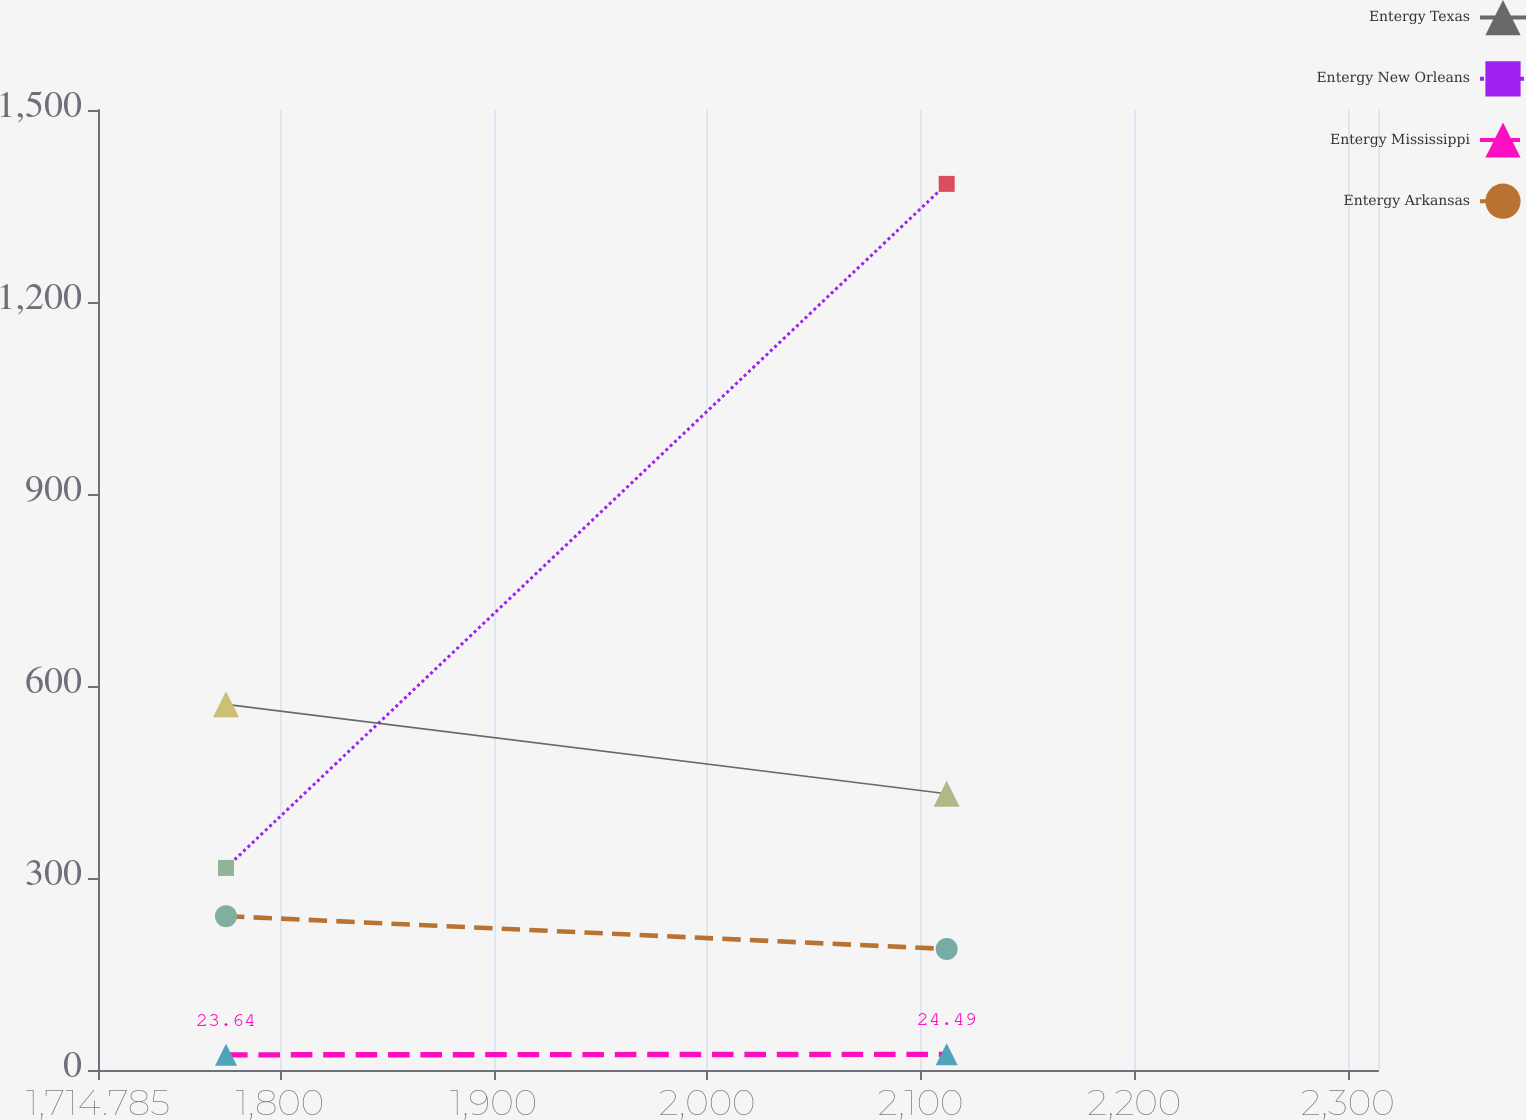Convert chart to OTSL. <chart><loc_0><loc_0><loc_500><loc_500><line_chart><ecel><fcel>Entergy Texas<fcel>Entergy New Orleans<fcel>Entergy Mississippi<fcel>Entergy Arkansas<nl><fcel>1774.72<fcel>571.34<fcel>315.76<fcel>23.64<fcel>240.4<nl><fcel>2112.18<fcel>431.52<fcel>1384.57<fcel>24.49<fcel>189.08<nl><fcel>2374.07<fcel>415.98<fcel>1246.26<fcel>21.63<fcel>171.44<nl></chart> 